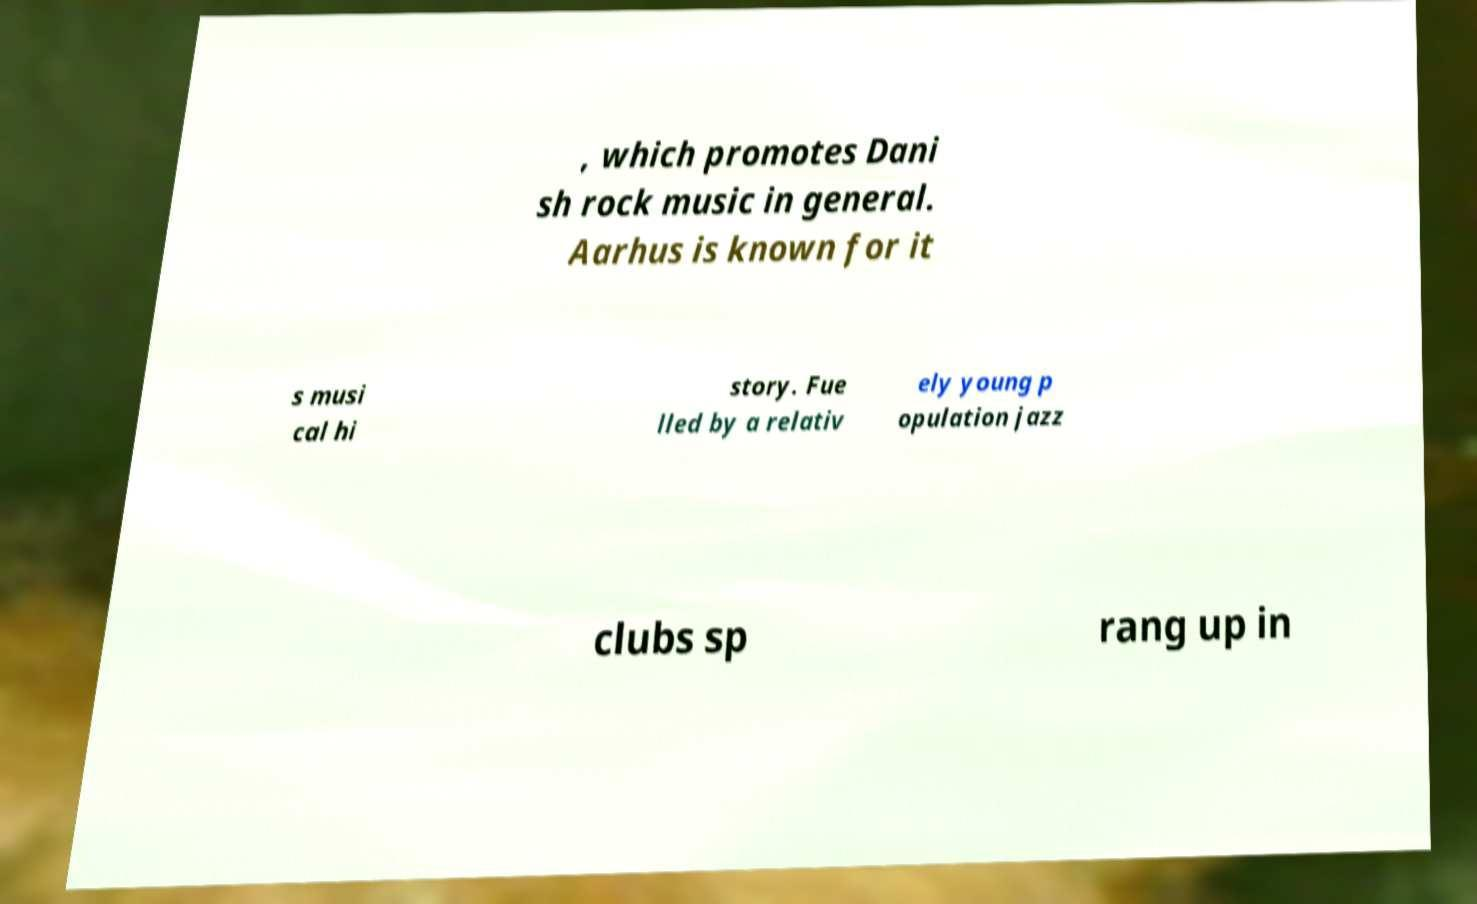Please read and relay the text visible in this image. What does it say? , which promotes Dani sh rock music in general. Aarhus is known for it s musi cal hi story. Fue lled by a relativ ely young p opulation jazz clubs sp rang up in 